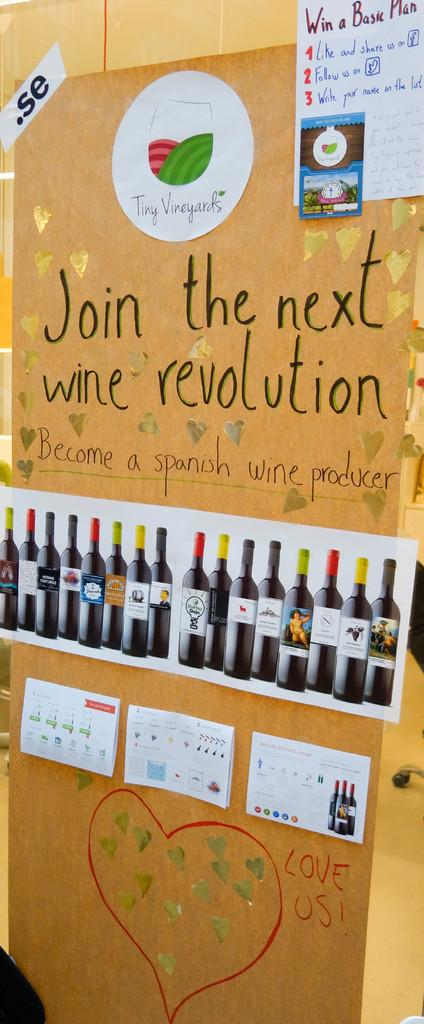<image>
Relay a brief, clear account of the picture shown. Yellow sign that says "Join the next wine revolution" on top. 